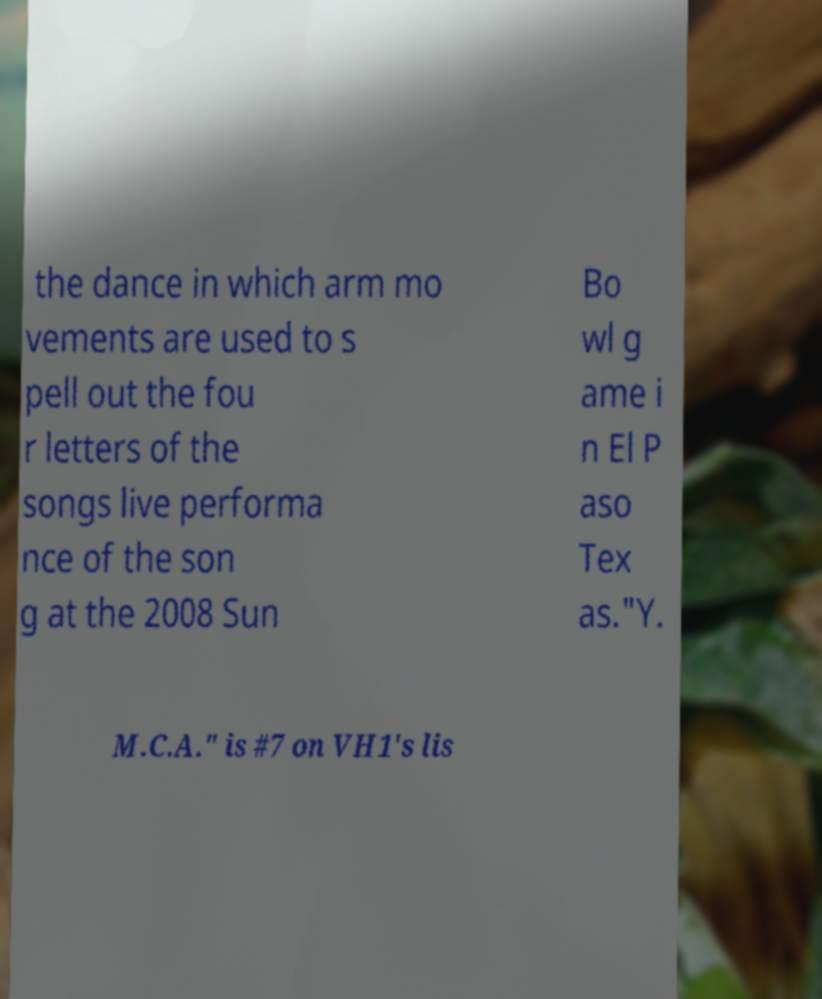Can you accurately transcribe the text from the provided image for me? the dance in which arm mo vements are used to s pell out the fou r letters of the songs live performa nce of the son g at the 2008 Sun Bo wl g ame i n El P aso Tex as."Y. M.C.A." is #7 on VH1's lis 